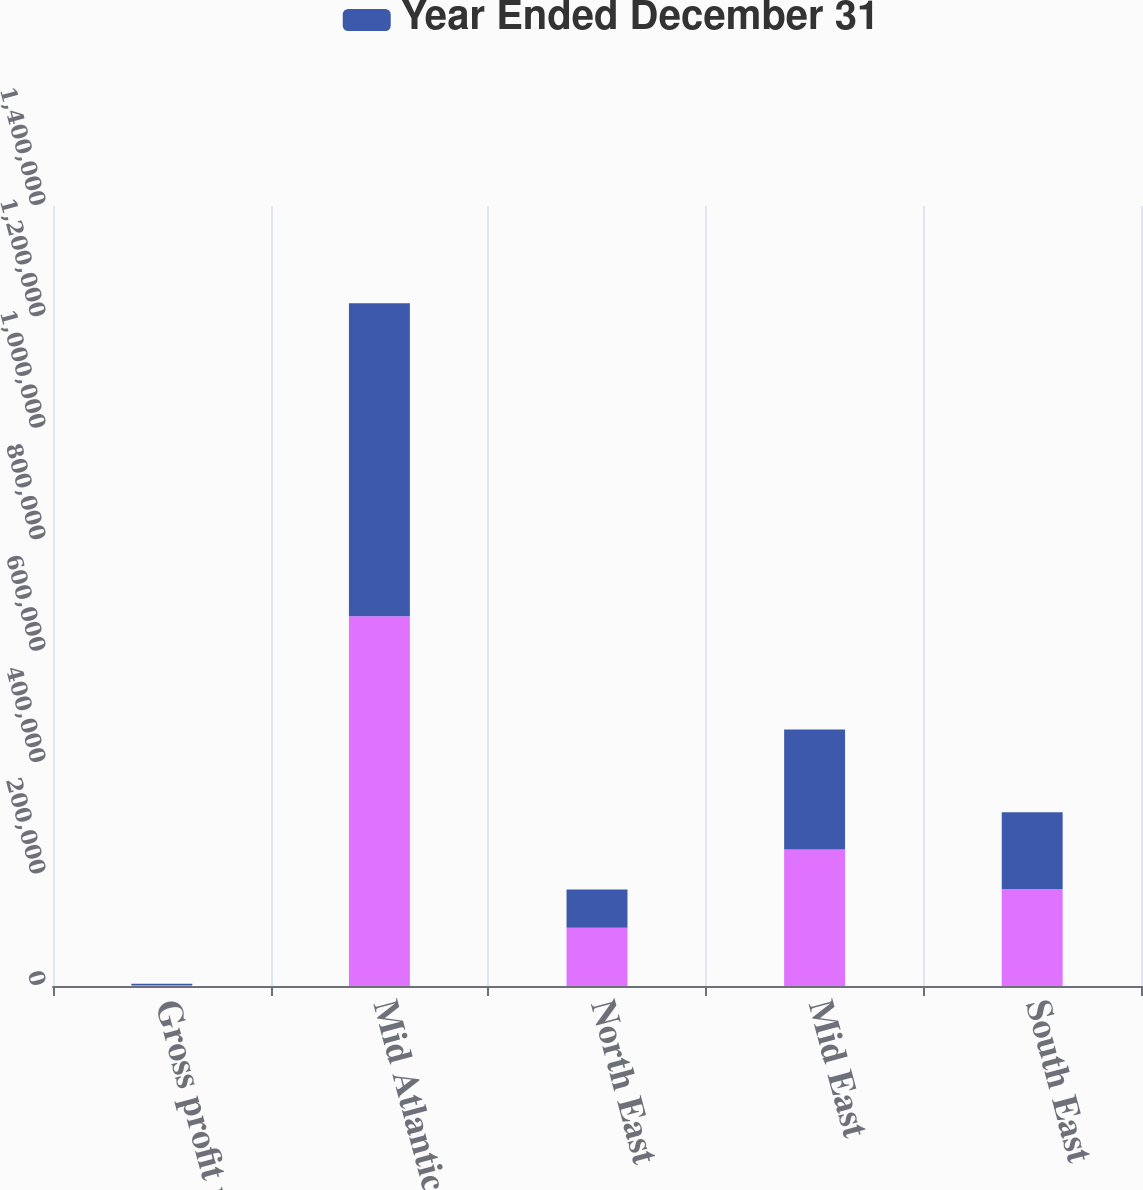Convert chart to OTSL. <chart><loc_0><loc_0><loc_500><loc_500><stacked_bar_chart><ecel><fcel>Gross profit margin<fcel>Mid Atlantic<fcel>North East<fcel>Mid East<fcel>South East<nl><fcel>nan<fcel>2017<fcel>663650<fcel>104501<fcel>244832<fcel>173961<nl><fcel>Year Ended December 31<fcel>2016<fcel>561857<fcel>68808<fcel>215335<fcel>137787<nl></chart> 